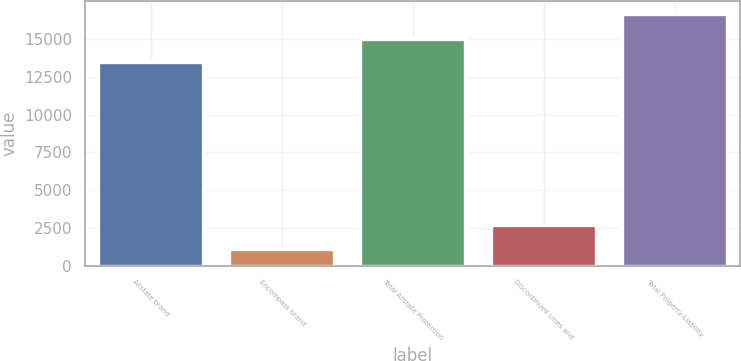Convert chart to OTSL. <chart><loc_0><loc_0><loc_500><loc_500><bar_chart><fcel>Allstate brand<fcel>Encompass brand<fcel>Total Allstate Protection<fcel>Discontinued Lines and<fcel>Total Property-Liability<nl><fcel>13456<fcel>1129<fcel>15009.1<fcel>2682.1<fcel>16660<nl></chart> 